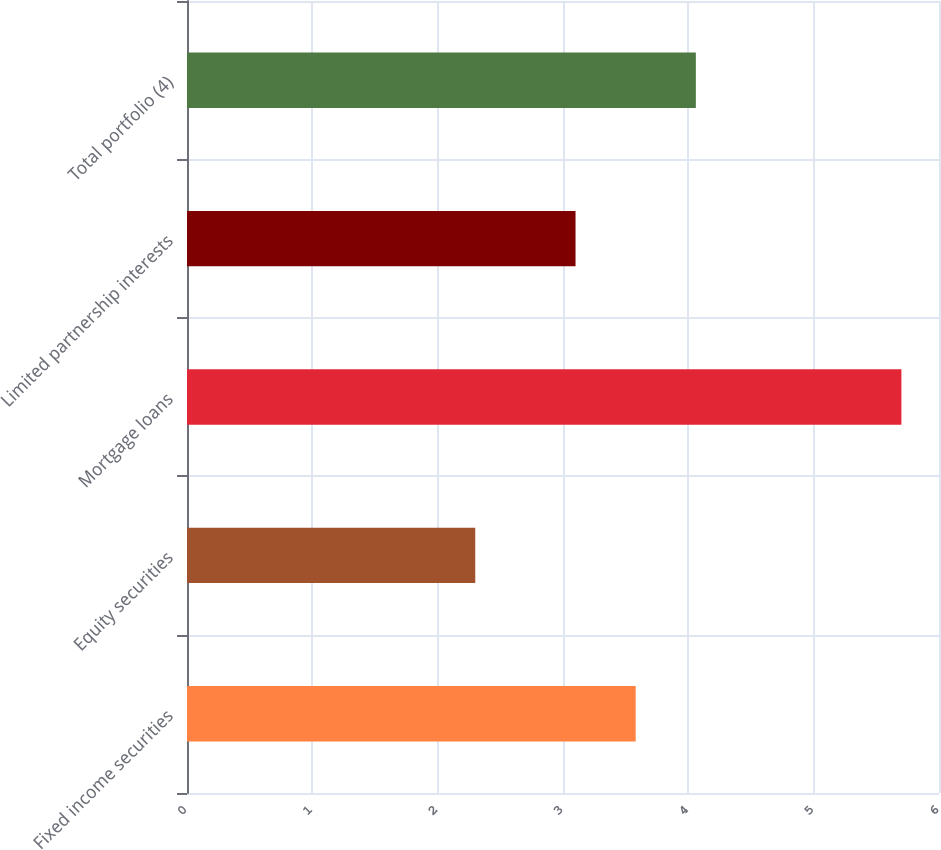<chart> <loc_0><loc_0><loc_500><loc_500><bar_chart><fcel>Fixed income securities<fcel>Equity securities<fcel>Mortgage loans<fcel>Limited partnership interests<fcel>Total portfolio (4)<nl><fcel>3.58<fcel>2.3<fcel>5.7<fcel>3.1<fcel>4.06<nl></chart> 